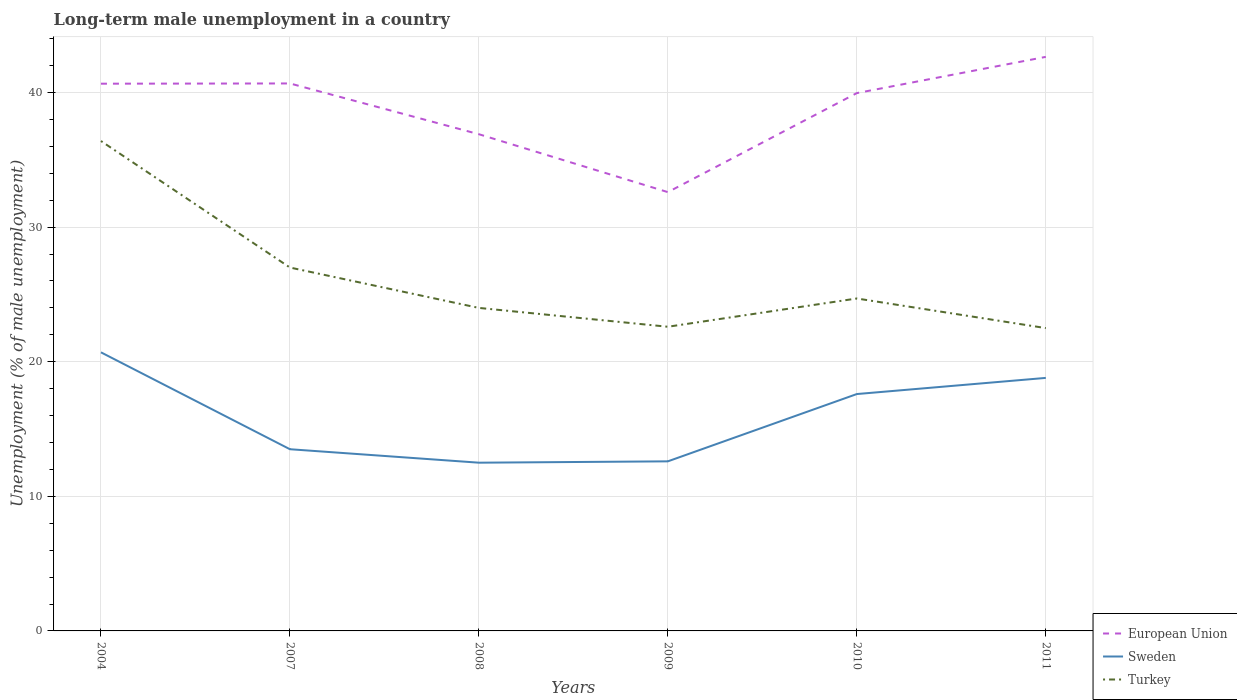How many different coloured lines are there?
Give a very brief answer. 3. Does the line corresponding to Sweden intersect with the line corresponding to European Union?
Provide a short and direct response. No. Across all years, what is the maximum percentage of long-term unemployed male population in Turkey?
Provide a succinct answer. 22.5. In which year was the percentage of long-term unemployed male population in Sweden maximum?
Your response must be concise. 2008. What is the total percentage of long-term unemployed male population in European Union in the graph?
Your answer should be very brief. 3.75. What is the difference between the highest and the second highest percentage of long-term unemployed male population in Turkey?
Ensure brevity in your answer.  13.9. Is the percentage of long-term unemployed male population in Turkey strictly greater than the percentage of long-term unemployed male population in Sweden over the years?
Keep it short and to the point. No. How many years are there in the graph?
Provide a short and direct response. 6. What is the difference between two consecutive major ticks on the Y-axis?
Offer a very short reply. 10. Are the values on the major ticks of Y-axis written in scientific E-notation?
Offer a terse response. No. Does the graph contain any zero values?
Offer a very short reply. No. Where does the legend appear in the graph?
Offer a terse response. Bottom right. How many legend labels are there?
Give a very brief answer. 3. How are the legend labels stacked?
Keep it short and to the point. Vertical. What is the title of the graph?
Your answer should be compact. Long-term male unemployment in a country. What is the label or title of the Y-axis?
Ensure brevity in your answer.  Unemployment (% of male unemployment). What is the Unemployment (% of male unemployment) in European Union in 2004?
Your answer should be very brief. 40.66. What is the Unemployment (% of male unemployment) in Sweden in 2004?
Your answer should be very brief. 20.7. What is the Unemployment (% of male unemployment) in Turkey in 2004?
Your response must be concise. 36.4. What is the Unemployment (% of male unemployment) in European Union in 2007?
Give a very brief answer. 40.68. What is the Unemployment (% of male unemployment) of European Union in 2008?
Give a very brief answer. 36.91. What is the Unemployment (% of male unemployment) of Sweden in 2008?
Your answer should be very brief. 12.5. What is the Unemployment (% of male unemployment) in European Union in 2009?
Your response must be concise. 32.6. What is the Unemployment (% of male unemployment) in Sweden in 2009?
Your answer should be very brief. 12.6. What is the Unemployment (% of male unemployment) of Turkey in 2009?
Your response must be concise. 22.6. What is the Unemployment (% of male unemployment) in European Union in 2010?
Give a very brief answer. 39.96. What is the Unemployment (% of male unemployment) in Sweden in 2010?
Provide a short and direct response. 17.6. What is the Unemployment (% of male unemployment) of Turkey in 2010?
Offer a very short reply. 24.7. What is the Unemployment (% of male unemployment) of European Union in 2011?
Offer a terse response. 42.65. What is the Unemployment (% of male unemployment) in Sweden in 2011?
Offer a very short reply. 18.8. Across all years, what is the maximum Unemployment (% of male unemployment) in European Union?
Keep it short and to the point. 42.65. Across all years, what is the maximum Unemployment (% of male unemployment) in Sweden?
Provide a succinct answer. 20.7. Across all years, what is the maximum Unemployment (% of male unemployment) in Turkey?
Keep it short and to the point. 36.4. Across all years, what is the minimum Unemployment (% of male unemployment) of European Union?
Your response must be concise. 32.6. What is the total Unemployment (% of male unemployment) in European Union in the graph?
Your answer should be very brief. 233.46. What is the total Unemployment (% of male unemployment) in Sweden in the graph?
Your answer should be compact. 95.7. What is the total Unemployment (% of male unemployment) in Turkey in the graph?
Offer a terse response. 157.2. What is the difference between the Unemployment (% of male unemployment) in European Union in 2004 and that in 2007?
Give a very brief answer. -0.02. What is the difference between the Unemployment (% of male unemployment) in European Union in 2004 and that in 2008?
Your response must be concise. 3.75. What is the difference between the Unemployment (% of male unemployment) in Turkey in 2004 and that in 2008?
Offer a terse response. 12.4. What is the difference between the Unemployment (% of male unemployment) of European Union in 2004 and that in 2009?
Provide a short and direct response. 8.06. What is the difference between the Unemployment (% of male unemployment) of European Union in 2004 and that in 2010?
Make the answer very short. 0.7. What is the difference between the Unemployment (% of male unemployment) of Turkey in 2004 and that in 2010?
Ensure brevity in your answer.  11.7. What is the difference between the Unemployment (% of male unemployment) in European Union in 2004 and that in 2011?
Give a very brief answer. -1.99. What is the difference between the Unemployment (% of male unemployment) of Turkey in 2004 and that in 2011?
Make the answer very short. 13.9. What is the difference between the Unemployment (% of male unemployment) of European Union in 2007 and that in 2008?
Your response must be concise. 3.77. What is the difference between the Unemployment (% of male unemployment) in Turkey in 2007 and that in 2008?
Offer a terse response. 3. What is the difference between the Unemployment (% of male unemployment) of European Union in 2007 and that in 2009?
Your response must be concise. 8.07. What is the difference between the Unemployment (% of male unemployment) in Turkey in 2007 and that in 2009?
Your answer should be very brief. 4.4. What is the difference between the Unemployment (% of male unemployment) in European Union in 2007 and that in 2010?
Provide a short and direct response. 0.72. What is the difference between the Unemployment (% of male unemployment) in Sweden in 2007 and that in 2010?
Your answer should be compact. -4.1. What is the difference between the Unemployment (% of male unemployment) in Turkey in 2007 and that in 2010?
Your answer should be very brief. 2.3. What is the difference between the Unemployment (% of male unemployment) in European Union in 2007 and that in 2011?
Your response must be concise. -1.98. What is the difference between the Unemployment (% of male unemployment) in Sweden in 2007 and that in 2011?
Your answer should be very brief. -5.3. What is the difference between the Unemployment (% of male unemployment) of European Union in 2008 and that in 2009?
Give a very brief answer. 4.3. What is the difference between the Unemployment (% of male unemployment) in Sweden in 2008 and that in 2009?
Keep it short and to the point. -0.1. What is the difference between the Unemployment (% of male unemployment) of European Union in 2008 and that in 2010?
Keep it short and to the point. -3.06. What is the difference between the Unemployment (% of male unemployment) of Sweden in 2008 and that in 2010?
Offer a very short reply. -5.1. What is the difference between the Unemployment (% of male unemployment) of Turkey in 2008 and that in 2010?
Keep it short and to the point. -0.7. What is the difference between the Unemployment (% of male unemployment) of European Union in 2008 and that in 2011?
Give a very brief answer. -5.75. What is the difference between the Unemployment (% of male unemployment) in Sweden in 2008 and that in 2011?
Your answer should be very brief. -6.3. What is the difference between the Unemployment (% of male unemployment) in European Union in 2009 and that in 2010?
Provide a succinct answer. -7.36. What is the difference between the Unemployment (% of male unemployment) in European Union in 2009 and that in 2011?
Your answer should be very brief. -10.05. What is the difference between the Unemployment (% of male unemployment) of Turkey in 2009 and that in 2011?
Your answer should be compact. 0.1. What is the difference between the Unemployment (% of male unemployment) of European Union in 2010 and that in 2011?
Offer a terse response. -2.69. What is the difference between the Unemployment (% of male unemployment) of Sweden in 2010 and that in 2011?
Keep it short and to the point. -1.2. What is the difference between the Unemployment (% of male unemployment) of Turkey in 2010 and that in 2011?
Your response must be concise. 2.2. What is the difference between the Unemployment (% of male unemployment) of European Union in 2004 and the Unemployment (% of male unemployment) of Sweden in 2007?
Provide a short and direct response. 27.16. What is the difference between the Unemployment (% of male unemployment) of European Union in 2004 and the Unemployment (% of male unemployment) of Turkey in 2007?
Provide a short and direct response. 13.66. What is the difference between the Unemployment (% of male unemployment) in Sweden in 2004 and the Unemployment (% of male unemployment) in Turkey in 2007?
Your answer should be compact. -6.3. What is the difference between the Unemployment (% of male unemployment) in European Union in 2004 and the Unemployment (% of male unemployment) in Sweden in 2008?
Your response must be concise. 28.16. What is the difference between the Unemployment (% of male unemployment) of European Union in 2004 and the Unemployment (% of male unemployment) of Turkey in 2008?
Ensure brevity in your answer.  16.66. What is the difference between the Unemployment (% of male unemployment) of European Union in 2004 and the Unemployment (% of male unemployment) of Sweden in 2009?
Provide a short and direct response. 28.06. What is the difference between the Unemployment (% of male unemployment) of European Union in 2004 and the Unemployment (% of male unemployment) of Turkey in 2009?
Keep it short and to the point. 18.06. What is the difference between the Unemployment (% of male unemployment) in Sweden in 2004 and the Unemployment (% of male unemployment) in Turkey in 2009?
Give a very brief answer. -1.9. What is the difference between the Unemployment (% of male unemployment) in European Union in 2004 and the Unemployment (% of male unemployment) in Sweden in 2010?
Keep it short and to the point. 23.06. What is the difference between the Unemployment (% of male unemployment) of European Union in 2004 and the Unemployment (% of male unemployment) of Turkey in 2010?
Your response must be concise. 15.96. What is the difference between the Unemployment (% of male unemployment) in European Union in 2004 and the Unemployment (% of male unemployment) in Sweden in 2011?
Provide a succinct answer. 21.86. What is the difference between the Unemployment (% of male unemployment) of European Union in 2004 and the Unemployment (% of male unemployment) of Turkey in 2011?
Your answer should be very brief. 18.16. What is the difference between the Unemployment (% of male unemployment) in Sweden in 2004 and the Unemployment (% of male unemployment) in Turkey in 2011?
Ensure brevity in your answer.  -1.8. What is the difference between the Unemployment (% of male unemployment) in European Union in 2007 and the Unemployment (% of male unemployment) in Sweden in 2008?
Offer a very short reply. 28.18. What is the difference between the Unemployment (% of male unemployment) in European Union in 2007 and the Unemployment (% of male unemployment) in Turkey in 2008?
Make the answer very short. 16.68. What is the difference between the Unemployment (% of male unemployment) of Sweden in 2007 and the Unemployment (% of male unemployment) of Turkey in 2008?
Your answer should be compact. -10.5. What is the difference between the Unemployment (% of male unemployment) of European Union in 2007 and the Unemployment (% of male unemployment) of Sweden in 2009?
Provide a succinct answer. 28.08. What is the difference between the Unemployment (% of male unemployment) of European Union in 2007 and the Unemployment (% of male unemployment) of Turkey in 2009?
Your answer should be compact. 18.08. What is the difference between the Unemployment (% of male unemployment) of Sweden in 2007 and the Unemployment (% of male unemployment) of Turkey in 2009?
Your response must be concise. -9.1. What is the difference between the Unemployment (% of male unemployment) in European Union in 2007 and the Unemployment (% of male unemployment) in Sweden in 2010?
Your response must be concise. 23.08. What is the difference between the Unemployment (% of male unemployment) in European Union in 2007 and the Unemployment (% of male unemployment) in Turkey in 2010?
Offer a very short reply. 15.98. What is the difference between the Unemployment (% of male unemployment) in European Union in 2007 and the Unemployment (% of male unemployment) in Sweden in 2011?
Offer a very short reply. 21.88. What is the difference between the Unemployment (% of male unemployment) of European Union in 2007 and the Unemployment (% of male unemployment) of Turkey in 2011?
Your answer should be compact. 18.18. What is the difference between the Unemployment (% of male unemployment) in Sweden in 2007 and the Unemployment (% of male unemployment) in Turkey in 2011?
Make the answer very short. -9. What is the difference between the Unemployment (% of male unemployment) of European Union in 2008 and the Unemployment (% of male unemployment) of Sweden in 2009?
Your response must be concise. 24.31. What is the difference between the Unemployment (% of male unemployment) in European Union in 2008 and the Unemployment (% of male unemployment) in Turkey in 2009?
Your response must be concise. 14.31. What is the difference between the Unemployment (% of male unemployment) in European Union in 2008 and the Unemployment (% of male unemployment) in Sweden in 2010?
Offer a terse response. 19.31. What is the difference between the Unemployment (% of male unemployment) of European Union in 2008 and the Unemployment (% of male unemployment) of Turkey in 2010?
Offer a terse response. 12.21. What is the difference between the Unemployment (% of male unemployment) of Sweden in 2008 and the Unemployment (% of male unemployment) of Turkey in 2010?
Provide a short and direct response. -12.2. What is the difference between the Unemployment (% of male unemployment) in European Union in 2008 and the Unemployment (% of male unemployment) in Sweden in 2011?
Provide a short and direct response. 18.11. What is the difference between the Unemployment (% of male unemployment) in European Union in 2008 and the Unemployment (% of male unemployment) in Turkey in 2011?
Give a very brief answer. 14.41. What is the difference between the Unemployment (% of male unemployment) of Sweden in 2008 and the Unemployment (% of male unemployment) of Turkey in 2011?
Offer a very short reply. -10. What is the difference between the Unemployment (% of male unemployment) in European Union in 2009 and the Unemployment (% of male unemployment) in Sweden in 2010?
Provide a short and direct response. 15. What is the difference between the Unemployment (% of male unemployment) in European Union in 2009 and the Unemployment (% of male unemployment) in Turkey in 2010?
Your answer should be very brief. 7.9. What is the difference between the Unemployment (% of male unemployment) in European Union in 2009 and the Unemployment (% of male unemployment) in Sweden in 2011?
Provide a short and direct response. 13.8. What is the difference between the Unemployment (% of male unemployment) in European Union in 2009 and the Unemployment (% of male unemployment) in Turkey in 2011?
Ensure brevity in your answer.  10.1. What is the difference between the Unemployment (% of male unemployment) of Sweden in 2009 and the Unemployment (% of male unemployment) of Turkey in 2011?
Make the answer very short. -9.9. What is the difference between the Unemployment (% of male unemployment) in European Union in 2010 and the Unemployment (% of male unemployment) in Sweden in 2011?
Your answer should be very brief. 21.16. What is the difference between the Unemployment (% of male unemployment) in European Union in 2010 and the Unemployment (% of male unemployment) in Turkey in 2011?
Provide a short and direct response. 17.46. What is the average Unemployment (% of male unemployment) of European Union per year?
Your answer should be compact. 38.91. What is the average Unemployment (% of male unemployment) of Sweden per year?
Your answer should be compact. 15.95. What is the average Unemployment (% of male unemployment) in Turkey per year?
Offer a terse response. 26.2. In the year 2004, what is the difference between the Unemployment (% of male unemployment) in European Union and Unemployment (% of male unemployment) in Sweden?
Ensure brevity in your answer.  19.96. In the year 2004, what is the difference between the Unemployment (% of male unemployment) of European Union and Unemployment (% of male unemployment) of Turkey?
Make the answer very short. 4.26. In the year 2004, what is the difference between the Unemployment (% of male unemployment) in Sweden and Unemployment (% of male unemployment) in Turkey?
Keep it short and to the point. -15.7. In the year 2007, what is the difference between the Unemployment (% of male unemployment) in European Union and Unemployment (% of male unemployment) in Sweden?
Keep it short and to the point. 27.18. In the year 2007, what is the difference between the Unemployment (% of male unemployment) in European Union and Unemployment (% of male unemployment) in Turkey?
Your answer should be compact. 13.68. In the year 2008, what is the difference between the Unemployment (% of male unemployment) in European Union and Unemployment (% of male unemployment) in Sweden?
Your answer should be compact. 24.41. In the year 2008, what is the difference between the Unemployment (% of male unemployment) in European Union and Unemployment (% of male unemployment) in Turkey?
Give a very brief answer. 12.91. In the year 2009, what is the difference between the Unemployment (% of male unemployment) in European Union and Unemployment (% of male unemployment) in Sweden?
Offer a terse response. 20. In the year 2009, what is the difference between the Unemployment (% of male unemployment) of European Union and Unemployment (% of male unemployment) of Turkey?
Provide a succinct answer. 10. In the year 2010, what is the difference between the Unemployment (% of male unemployment) of European Union and Unemployment (% of male unemployment) of Sweden?
Give a very brief answer. 22.36. In the year 2010, what is the difference between the Unemployment (% of male unemployment) in European Union and Unemployment (% of male unemployment) in Turkey?
Offer a very short reply. 15.26. In the year 2010, what is the difference between the Unemployment (% of male unemployment) of Sweden and Unemployment (% of male unemployment) of Turkey?
Make the answer very short. -7.1. In the year 2011, what is the difference between the Unemployment (% of male unemployment) of European Union and Unemployment (% of male unemployment) of Sweden?
Provide a succinct answer. 23.85. In the year 2011, what is the difference between the Unemployment (% of male unemployment) in European Union and Unemployment (% of male unemployment) in Turkey?
Give a very brief answer. 20.15. What is the ratio of the Unemployment (% of male unemployment) of European Union in 2004 to that in 2007?
Ensure brevity in your answer.  1. What is the ratio of the Unemployment (% of male unemployment) of Sweden in 2004 to that in 2007?
Provide a succinct answer. 1.53. What is the ratio of the Unemployment (% of male unemployment) in Turkey in 2004 to that in 2007?
Your answer should be compact. 1.35. What is the ratio of the Unemployment (% of male unemployment) in European Union in 2004 to that in 2008?
Offer a terse response. 1.1. What is the ratio of the Unemployment (% of male unemployment) of Sweden in 2004 to that in 2008?
Provide a succinct answer. 1.66. What is the ratio of the Unemployment (% of male unemployment) of Turkey in 2004 to that in 2008?
Your answer should be very brief. 1.52. What is the ratio of the Unemployment (% of male unemployment) in European Union in 2004 to that in 2009?
Your answer should be very brief. 1.25. What is the ratio of the Unemployment (% of male unemployment) of Sweden in 2004 to that in 2009?
Give a very brief answer. 1.64. What is the ratio of the Unemployment (% of male unemployment) of Turkey in 2004 to that in 2009?
Give a very brief answer. 1.61. What is the ratio of the Unemployment (% of male unemployment) of European Union in 2004 to that in 2010?
Offer a terse response. 1.02. What is the ratio of the Unemployment (% of male unemployment) of Sweden in 2004 to that in 2010?
Your answer should be compact. 1.18. What is the ratio of the Unemployment (% of male unemployment) in Turkey in 2004 to that in 2010?
Keep it short and to the point. 1.47. What is the ratio of the Unemployment (% of male unemployment) of European Union in 2004 to that in 2011?
Offer a terse response. 0.95. What is the ratio of the Unemployment (% of male unemployment) of Sweden in 2004 to that in 2011?
Give a very brief answer. 1.1. What is the ratio of the Unemployment (% of male unemployment) of Turkey in 2004 to that in 2011?
Ensure brevity in your answer.  1.62. What is the ratio of the Unemployment (% of male unemployment) in European Union in 2007 to that in 2008?
Keep it short and to the point. 1.1. What is the ratio of the Unemployment (% of male unemployment) in Turkey in 2007 to that in 2008?
Provide a succinct answer. 1.12. What is the ratio of the Unemployment (% of male unemployment) in European Union in 2007 to that in 2009?
Your response must be concise. 1.25. What is the ratio of the Unemployment (% of male unemployment) of Sweden in 2007 to that in 2009?
Your answer should be very brief. 1.07. What is the ratio of the Unemployment (% of male unemployment) in Turkey in 2007 to that in 2009?
Provide a succinct answer. 1.19. What is the ratio of the Unemployment (% of male unemployment) of European Union in 2007 to that in 2010?
Provide a short and direct response. 1.02. What is the ratio of the Unemployment (% of male unemployment) in Sweden in 2007 to that in 2010?
Provide a succinct answer. 0.77. What is the ratio of the Unemployment (% of male unemployment) in Turkey in 2007 to that in 2010?
Ensure brevity in your answer.  1.09. What is the ratio of the Unemployment (% of male unemployment) in European Union in 2007 to that in 2011?
Provide a succinct answer. 0.95. What is the ratio of the Unemployment (% of male unemployment) of Sweden in 2007 to that in 2011?
Keep it short and to the point. 0.72. What is the ratio of the Unemployment (% of male unemployment) of European Union in 2008 to that in 2009?
Give a very brief answer. 1.13. What is the ratio of the Unemployment (% of male unemployment) in Turkey in 2008 to that in 2009?
Ensure brevity in your answer.  1.06. What is the ratio of the Unemployment (% of male unemployment) of European Union in 2008 to that in 2010?
Offer a very short reply. 0.92. What is the ratio of the Unemployment (% of male unemployment) in Sweden in 2008 to that in 2010?
Your response must be concise. 0.71. What is the ratio of the Unemployment (% of male unemployment) of Turkey in 2008 to that in 2010?
Provide a succinct answer. 0.97. What is the ratio of the Unemployment (% of male unemployment) of European Union in 2008 to that in 2011?
Offer a terse response. 0.87. What is the ratio of the Unemployment (% of male unemployment) of Sweden in 2008 to that in 2011?
Offer a terse response. 0.66. What is the ratio of the Unemployment (% of male unemployment) in Turkey in 2008 to that in 2011?
Your answer should be very brief. 1.07. What is the ratio of the Unemployment (% of male unemployment) in European Union in 2009 to that in 2010?
Ensure brevity in your answer.  0.82. What is the ratio of the Unemployment (% of male unemployment) of Sweden in 2009 to that in 2010?
Provide a short and direct response. 0.72. What is the ratio of the Unemployment (% of male unemployment) of Turkey in 2009 to that in 2010?
Your answer should be very brief. 0.92. What is the ratio of the Unemployment (% of male unemployment) of European Union in 2009 to that in 2011?
Offer a terse response. 0.76. What is the ratio of the Unemployment (% of male unemployment) of Sweden in 2009 to that in 2011?
Keep it short and to the point. 0.67. What is the ratio of the Unemployment (% of male unemployment) of European Union in 2010 to that in 2011?
Provide a short and direct response. 0.94. What is the ratio of the Unemployment (% of male unemployment) in Sweden in 2010 to that in 2011?
Offer a terse response. 0.94. What is the ratio of the Unemployment (% of male unemployment) of Turkey in 2010 to that in 2011?
Make the answer very short. 1.1. What is the difference between the highest and the second highest Unemployment (% of male unemployment) in European Union?
Give a very brief answer. 1.98. What is the difference between the highest and the second highest Unemployment (% of male unemployment) in Turkey?
Offer a terse response. 9.4. What is the difference between the highest and the lowest Unemployment (% of male unemployment) in European Union?
Give a very brief answer. 10.05. What is the difference between the highest and the lowest Unemployment (% of male unemployment) of Turkey?
Provide a short and direct response. 13.9. 